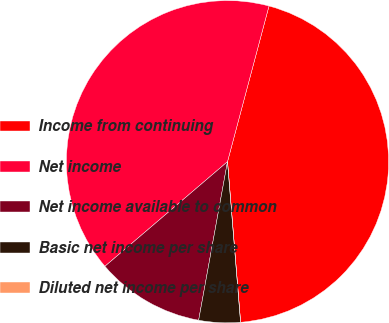Convert chart to OTSL. <chart><loc_0><loc_0><loc_500><loc_500><pie_chart><fcel>Income from continuing<fcel>Net income<fcel>Net income available to common<fcel>Basic net income per share<fcel>Diluted net income per share<nl><fcel>44.56%<fcel>40.39%<fcel>10.89%<fcel>4.16%<fcel>0.0%<nl></chart> 